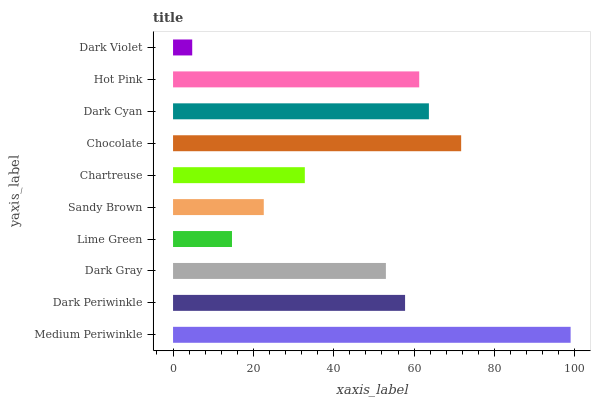Is Dark Violet the minimum?
Answer yes or no. Yes. Is Medium Periwinkle the maximum?
Answer yes or no. Yes. Is Dark Periwinkle the minimum?
Answer yes or no. No. Is Dark Periwinkle the maximum?
Answer yes or no. No. Is Medium Periwinkle greater than Dark Periwinkle?
Answer yes or no. Yes. Is Dark Periwinkle less than Medium Periwinkle?
Answer yes or no. Yes. Is Dark Periwinkle greater than Medium Periwinkle?
Answer yes or no. No. Is Medium Periwinkle less than Dark Periwinkle?
Answer yes or no. No. Is Dark Periwinkle the high median?
Answer yes or no. Yes. Is Dark Gray the low median?
Answer yes or no. Yes. Is Dark Violet the high median?
Answer yes or no. No. Is Lime Green the low median?
Answer yes or no. No. 